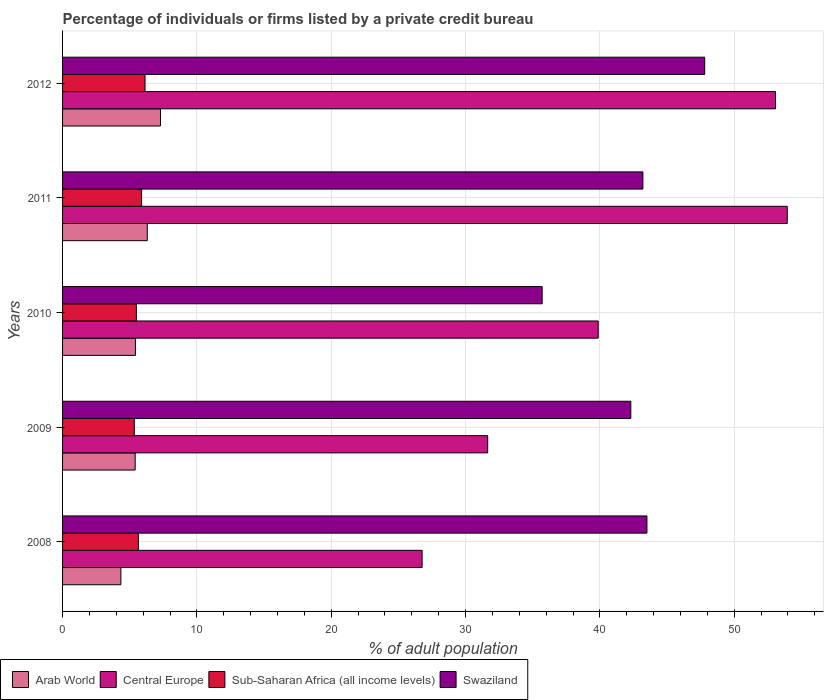How many different coloured bars are there?
Provide a succinct answer. 4. Are the number of bars on each tick of the Y-axis equal?
Provide a short and direct response. Yes. What is the label of the 1st group of bars from the top?
Ensure brevity in your answer.  2012. What is the percentage of population listed by a private credit bureau in Sub-Saharan Africa (all income levels) in 2009?
Offer a terse response. 5.34. Across all years, what is the maximum percentage of population listed by a private credit bureau in Central Europe?
Your answer should be compact. 53.95. Across all years, what is the minimum percentage of population listed by a private credit bureau in Central Europe?
Provide a succinct answer. 26.76. What is the total percentage of population listed by a private credit bureau in Swaziland in the graph?
Ensure brevity in your answer.  212.5. What is the difference between the percentage of population listed by a private credit bureau in Sub-Saharan Africa (all income levels) in 2008 and that in 2011?
Provide a short and direct response. -0.24. What is the difference between the percentage of population listed by a private credit bureau in Central Europe in 2010 and the percentage of population listed by a private credit bureau in Swaziland in 2011?
Make the answer very short. -3.33. What is the average percentage of population listed by a private credit bureau in Swaziland per year?
Keep it short and to the point. 42.5. In the year 2012, what is the difference between the percentage of population listed by a private credit bureau in Arab World and percentage of population listed by a private credit bureau in Sub-Saharan Africa (all income levels)?
Your answer should be very brief. 1.15. In how many years, is the percentage of population listed by a private credit bureau in Swaziland greater than 52 %?
Your answer should be very brief. 0. What is the ratio of the percentage of population listed by a private credit bureau in Central Europe in 2011 to that in 2012?
Keep it short and to the point. 1.02. Is the percentage of population listed by a private credit bureau in Arab World in 2008 less than that in 2012?
Keep it short and to the point. Yes. What is the difference between the highest and the second highest percentage of population listed by a private credit bureau in Arab World?
Keep it short and to the point. 0.99. What is the difference between the highest and the lowest percentage of population listed by a private credit bureau in Swaziland?
Keep it short and to the point. 12.1. What does the 4th bar from the top in 2009 represents?
Offer a very short reply. Arab World. What does the 4th bar from the bottom in 2012 represents?
Keep it short and to the point. Swaziland. Are all the bars in the graph horizontal?
Ensure brevity in your answer.  Yes. What is the difference between two consecutive major ticks on the X-axis?
Your response must be concise. 10. Where does the legend appear in the graph?
Provide a succinct answer. Bottom left. How are the legend labels stacked?
Give a very brief answer. Horizontal. What is the title of the graph?
Offer a terse response. Percentage of individuals or firms listed by a private credit bureau. Does "Malaysia" appear as one of the legend labels in the graph?
Provide a short and direct response. No. What is the label or title of the X-axis?
Your answer should be compact. % of adult population. What is the % of adult population of Arab World in 2008?
Your answer should be compact. 4.34. What is the % of adult population in Central Europe in 2008?
Your answer should be very brief. 26.76. What is the % of adult population of Sub-Saharan Africa (all income levels) in 2008?
Offer a very short reply. 5.64. What is the % of adult population in Swaziland in 2008?
Give a very brief answer. 43.5. What is the % of adult population of Arab World in 2009?
Give a very brief answer. 5.41. What is the % of adult population in Central Europe in 2009?
Your answer should be compact. 31.65. What is the % of adult population of Sub-Saharan Africa (all income levels) in 2009?
Give a very brief answer. 5.34. What is the % of adult population of Swaziland in 2009?
Provide a succinct answer. 42.3. What is the % of adult population in Arab World in 2010?
Give a very brief answer. 5.42. What is the % of adult population in Central Europe in 2010?
Give a very brief answer. 39.87. What is the % of adult population of Sub-Saharan Africa (all income levels) in 2010?
Your answer should be very brief. 5.49. What is the % of adult population of Swaziland in 2010?
Provide a succinct answer. 35.7. What is the % of adult population in Arab World in 2011?
Make the answer very short. 6.3. What is the % of adult population of Central Europe in 2011?
Offer a terse response. 53.95. What is the % of adult population in Sub-Saharan Africa (all income levels) in 2011?
Make the answer very short. 5.88. What is the % of adult population in Swaziland in 2011?
Your response must be concise. 43.2. What is the % of adult population of Arab World in 2012?
Your answer should be very brief. 7.29. What is the % of adult population of Central Europe in 2012?
Your answer should be compact. 53.07. What is the % of adult population of Sub-Saharan Africa (all income levels) in 2012?
Keep it short and to the point. 6.14. What is the % of adult population in Swaziland in 2012?
Provide a succinct answer. 47.8. Across all years, what is the maximum % of adult population of Arab World?
Keep it short and to the point. 7.29. Across all years, what is the maximum % of adult population in Central Europe?
Your answer should be compact. 53.95. Across all years, what is the maximum % of adult population of Sub-Saharan Africa (all income levels)?
Your answer should be compact. 6.14. Across all years, what is the maximum % of adult population in Swaziland?
Ensure brevity in your answer.  47.8. Across all years, what is the minimum % of adult population in Arab World?
Ensure brevity in your answer.  4.34. Across all years, what is the minimum % of adult population of Central Europe?
Give a very brief answer. 26.76. Across all years, what is the minimum % of adult population in Sub-Saharan Africa (all income levels)?
Provide a succinct answer. 5.34. Across all years, what is the minimum % of adult population in Swaziland?
Offer a very short reply. 35.7. What is the total % of adult population in Arab World in the graph?
Make the answer very short. 28.77. What is the total % of adult population of Central Europe in the graph?
Offer a very short reply. 205.3. What is the total % of adult population in Sub-Saharan Africa (all income levels) in the graph?
Your answer should be compact. 28.5. What is the total % of adult population in Swaziland in the graph?
Offer a very short reply. 212.5. What is the difference between the % of adult population in Arab World in 2008 and that in 2009?
Your response must be concise. -1.06. What is the difference between the % of adult population of Central Europe in 2008 and that in 2009?
Ensure brevity in your answer.  -4.88. What is the difference between the % of adult population of Sub-Saharan Africa (all income levels) in 2008 and that in 2009?
Provide a succinct answer. 0.3. What is the difference between the % of adult population of Arab World in 2008 and that in 2010?
Provide a succinct answer. -1.08. What is the difference between the % of adult population of Central Europe in 2008 and that in 2010?
Give a very brief answer. -13.11. What is the difference between the % of adult population of Sub-Saharan Africa (all income levels) in 2008 and that in 2010?
Your answer should be compact. 0.15. What is the difference between the % of adult population of Arab World in 2008 and that in 2011?
Your answer should be very brief. -1.97. What is the difference between the % of adult population of Central Europe in 2008 and that in 2011?
Offer a terse response. -27.18. What is the difference between the % of adult population in Sub-Saharan Africa (all income levels) in 2008 and that in 2011?
Offer a terse response. -0.24. What is the difference between the % of adult population of Arab World in 2008 and that in 2012?
Your answer should be very brief. -2.95. What is the difference between the % of adult population of Central Europe in 2008 and that in 2012?
Make the answer very short. -26.31. What is the difference between the % of adult population in Sub-Saharan Africa (all income levels) in 2008 and that in 2012?
Your response must be concise. -0.49. What is the difference between the % of adult population in Swaziland in 2008 and that in 2012?
Your answer should be compact. -4.3. What is the difference between the % of adult population of Arab World in 2009 and that in 2010?
Your response must be concise. -0.02. What is the difference between the % of adult population in Central Europe in 2009 and that in 2010?
Keep it short and to the point. -8.23. What is the difference between the % of adult population in Sub-Saharan Africa (all income levels) in 2009 and that in 2010?
Keep it short and to the point. -0.15. What is the difference between the % of adult population in Swaziland in 2009 and that in 2010?
Provide a short and direct response. 6.6. What is the difference between the % of adult population in Central Europe in 2009 and that in 2011?
Ensure brevity in your answer.  -22.3. What is the difference between the % of adult population in Sub-Saharan Africa (all income levels) in 2009 and that in 2011?
Your answer should be compact. -0.54. What is the difference between the % of adult population in Swaziland in 2009 and that in 2011?
Offer a very short reply. -0.9. What is the difference between the % of adult population in Arab World in 2009 and that in 2012?
Provide a short and direct response. -1.89. What is the difference between the % of adult population in Central Europe in 2009 and that in 2012?
Provide a short and direct response. -21.43. What is the difference between the % of adult population of Sub-Saharan Africa (all income levels) in 2009 and that in 2012?
Ensure brevity in your answer.  -0.8. What is the difference between the % of adult population of Arab World in 2010 and that in 2011?
Offer a terse response. -0.88. What is the difference between the % of adult population of Central Europe in 2010 and that in 2011?
Your response must be concise. -14.07. What is the difference between the % of adult population in Sub-Saharan Africa (all income levels) in 2010 and that in 2011?
Your answer should be compact. -0.39. What is the difference between the % of adult population in Swaziland in 2010 and that in 2011?
Give a very brief answer. -7.5. What is the difference between the % of adult population in Arab World in 2010 and that in 2012?
Offer a very short reply. -1.87. What is the difference between the % of adult population of Central Europe in 2010 and that in 2012?
Ensure brevity in your answer.  -13.2. What is the difference between the % of adult population in Sub-Saharan Africa (all income levels) in 2010 and that in 2012?
Keep it short and to the point. -0.65. What is the difference between the % of adult population in Swaziland in 2010 and that in 2012?
Keep it short and to the point. -12.1. What is the difference between the % of adult population of Arab World in 2011 and that in 2012?
Offer a very short reply. -0.99. What is the difference between the % of adult population of Central Europe in 2011 and that in 2012?
Make the answer very short. 0.87. What is the difference between the % of adult population in Sub-Saharan Africa (all income levels) in 2011 and that in 2012?
Your answer should be compact. -0.26. What is the difference between the % of adult population in Arab World in 2008 and the % of adult population in Central Europe in 2009?
Your answer should be very brief. -27.31. What is the difference between the % of adult population of Arab World in 2008 and the % of adult population of Swaziland in 2009?
Ensure brevity in your answer.  -37.96. What is the difference between the % of adult population in Central Europe in 2008 and the % of adult population in Sub-Saharan Africa (all income levels) in 2009?
Offer a very short reply. 21.42. What is the difference between the % of adult population of Central Europe in 2008 and the % of adult population of Swaziland in 2009?
Offer a terse response. -15.54. What is the difference between the % of adult population in Sub-Saharan Africa (all income levels) in 2008 and the % of adult population in Swaziland in 2009?
Your answer should be compact. -36.66. What is the difference between the % of adult population in Arab World in 2008 and the % of adult population in Central Europe in 2010?
Provide a succinct answer. -35.53. What is the difference between the % of adult population in Arab World in 2008 and the % of adult population in Sub-Saharan Africa (all income levels) in 2010?
Ensure brevity in your answer.  -1.15. What is the difference between the % of adult population of Arab World in 2008 and the % of adult population of Swaziland in 2010?
Keep it short and to the point. -31.36. What is the difference between the % of adult population of Central Europe in 2008 and the % of adult population of Sub-Saharan Africa (all income levels) in 2010?
Keep it short and to the point. 21.27. What is the difference between the % of adult population of Central Europe in 2008 and the % of adult population of Swaziland in 2010?
Provide a short and direct response. -8.94. What is the difference between the % of adult population of Sub-Saharan Africa (all income levels) in 2008 and the % of adult population of Swaziland in 2010?
Make the answer very short. -30.06. What is the difference between the % of adult population of Arab World in 2008 and the % of adult population of Central Europe in 2011?
Provide a succinct answer. -49.61. What is the difference between the % of adult population in Arab World in 2008 and the % of adult population in Sub-Saharan Africa (all income levels) in 2011?
Your response must be concise. -1.54. What is the difference between the % of adult population in Arab World in 2008 and the % of adult population in Swaziland in 2011?
Provide a short and direct response. -38.86. What is the difference between the % of adult population in Central Europe in 2008 and the % of adult population in Sub-Saharan Africa (all income levels) in 2011?
Your answer should be very brief. 20.88. What is the difference between the % of adult population of Central Europe in 2008 and the % of adult population of Swaziland in 2011?
Ensure brevity in your answer.  -16.44. What is the difference between the % of adult population in Sub-Saharan Africa (all income levels) in 2008 and the % of adult population in Swaziland in 2011?
Provide a short and direct response. -37.56. What is the difference between the % of adult population of Arab World in 2008 and the % of adult population of Central Europe in 2012?
Offer a terse response. -48.73. What is the difference between the % of adult population in Arab World in 2008 and the % of adult population in Sub-Saharan Africa (all income levels) in 2012?
Provide a short and direct response. -1.8. What is the difference between the % of adult population of Arab World in 2008 and the % of adult population of Swaziland in 2012?
Your answer should be very brief. -43.46. What is the difference between the % of adult population in Central Europe in 2008 and the % of adult population in Sub-Saharan Africa (all income levels) in 2012?
Make the answer very short. 20.62. What is the difference between the % of adult population of Central Europe in 2008 and the % of adult population of Swaziland in 2012?
Offer a very short reply. -21.04. What is the difference between the % of adult population of Sub-Saharan Africa (all income levels) in 2008 and the % of adult population of Swaziland in 2012?
Your answer should be very brief. -42.16. What is the difference between the % of adult population in Arab World in 2009 and the % of adult population in Central Europe in 2010?
Keep it short and to the point. -34.47. What is the difference between the % of adult population of Arab World in 2009 and the % of adult population of Sub-Saharan Africa (all income levels) in 2010?
Your answer should be compact. -0.09. What is the difference between the % of adult population of Arab World in 2009 and the % of adult population of Swaziland in 2010?
Keep it short and to the point. -30.3. What is the difference between the % of adult population of Central Europe in 2009 and the % of adult population of Sub-Saharan Africa (all income levels) in 2010?
Provide a short and direct response. 26.15. What is the difference between the % of adult population of Central Europe in 2009 and the % of adult population of Swaziland in 2010?
Offer a terse response. -4.05. What is the difference between the % of adult population of Sub-Saharan Africa (all income levels) in 2009 and the % of adult population of Swaziland in 2010?
Keep it short and to the point. -30.36. What is the difference between the % of adult population in Arab World in 2009 and the % of adult population in Central Europe in 2011?
Offer a very short reply. -48.54. What is the difference between the % of adult population in Arab World in 2009 and the % of adult population in Sub-Saharan Africa (all income levels) in 2011?
Your answer should be very brief. -0.47. What is the difference between the % of adult population of Arab World in 2009 and the % of adult population of Swaziland in 2011?
Your answer should be very brief. -37.8. What is the difference between the % of adult population in Central Europe in 2009 and the % of adult population in Sub-Saharan Africa (all income levels) in 2011?
Your answer should be compact. 25.77. What is the difference between the % of adult population in Central Europe in 2009 and the % of adult population in Swaziland in 2011?
Ensure brevity in your answer.  -11.55. What is the difference between the % of adult population of Sub-Saharan Africa (all income levels) in 2009 and the % of adult population of Swaziland in 2011?
Your response must be concise. -37.86. What is the difference between the % of adult population of Arab World in 2009 and the % of adult population of Central Europe in 2012?
Your answer should be very brief. -47.67. What is the difference between the % of adult population in Arab World in 2009 and the % of adult population in Sub-Saharan Africa (all income levels) in 2012?
Offer a terse response. -0.73. What is the difference between the % of adult population in Arab World in 2009 and the % of adult population in Swaziland in 2012?
Provide a short and direct response. -42.4. What is the difference between the % of adult population of Central Europe in 2009 and the % of adult population of Sub-Saharan Africa (all income levels) in 2012?
Keep it short and to the point. 25.51. What is the difference between the % of adult population of Central Europe in 2009 and the % of adult population of Swaziland in 2012?
Ensure brevity in your answer.  -16.15. What is the difference between the % of adult population of Sub-Saharan Africa (all income levels) in 2009 and the % of adult population of Swaziland in 2012?
Offer a very short reply. -42.46. What is the difference between the % of adult population in Arab World in 2010 and the % of adult population in Central Europe in 2011?
Offer a very short reply. -48.52. What is the difference between the % of adult population in Arab World in 2010 and the % of adult population in Sub-Saharan Africa (all income levels) in 2011?
Provide a succinct answer. -0.46. What is the difference between the % of adult population of Arab World in 2010 and the % of adult population of Swaziland in 2011?
Keep it short and to the point. -37.77. What is the difference between the % of adult population in Central Europe in 2010 and the % of adult population in Sub-Saharan Africa (all income levels) in 2011?
Provide a short and direct response. 33.99. What is the difference between the % of adult population in Central Europe in 2010 and the % of adult population in Swaziland in 2011?
Give a very brief answer. -3.33. What is the difference between the % of adult population of Sub-Saharan Africa (all income levels) in 2010 and the % of adult population of Swaziland in 2011?
Your answer should be compact. -37.71. What is the difference between the % of adult population of Arab World in 2010 and the % of adult population of Central Europe in 2012?
Your answer should be compact. -47.65. What is the difference between the % of adult population of Arab World in 2010 and the % of adult population of Sub-Saharan Africa (all income levels) in 2012?
Provide a short and direct response. -0.71. What is the difference between the % of adult population of Arab World in 2010 and the % of adult population of Swaziland in 2012?
Make the answer very short. -42.38. What is the difference between the % of adult population in Central Europe in 2010 and the % of adult population in Sub-Saharan Africa (all income levels) in 2012?
Ensure brevity in your answer.  33.73. What is the difference between the % of adult population of Central Europe in 2010 and the % of adult population of Swaziland in 2012?
Your answer should be very brief. -7.93. What is the difference between the % of adult population in Sub-Saharan Africa (all income levels) in 2010 and the % of adult population in Swaziland in 2012?
Keep it short and to the point. -42.31. What is the difference between the % of adult population of Arab World in 2011 and the % of adult population of Central Europe in 2012?
Ensure brevity in your answer.  -46.77. What is the difference between the % of adult population of Arab World in 2011 and the % of adult population of Sub-Saharan Africa (all income levels) in 2012?
Offer a terse response. 0.17. What is the difference between the % of adult population in Arab World in 2011 and the % of adult population in Swaziland in 2012?
Offer a very short reply. -41.49. What is the difference between the % of adult population of Central Europe in 2011 and the % of adult population of Sub-Saharan Africa (all income levels) in 2012?
Make the answer very short. 47.81. What is the difference between the % of adult population of Central Europe in 2011 and the % of adult population of Swaziland in 2012?
Your answer should be very brief. 6.15. What is the difference between the % of adult population in Sub-Saharan Africa (all income levels) in 2011 and the % of adult population in Swaziland in 2012?
Offer a very short reply. -41.92. What is the average % of adult population of Arab World per year?
Provide a short and direct response. 5.75. What is the average % of adult population of Central Europe per year?
Give a very brief answer. 41.06. What is the average % of adult population in Sub-Saharan Africa (all income levels) per year?
Offer a terse response. 5.7. What is the average % of adult population of Swaziland per year?
Your response must be concise. 42.5. In the year 2008, what is the difference between the % of adult population of Arab World and % of adult population of Central Europe?
Offer a terse response. -22.42. In the year 2008, what is the difference between the % of adult population of Arab World and % of adult population of Sub-Saharan Africa (all income levels)?
Provide a short and direct response. -1.3. In the year 2008, what is the difference between the % of adult population in Arab World and % of adult population in Swaziland?
Make the answer very short. -39.16. In the year 2008, what is the difference between the % of adult population of Central Europe and % of adult population of Sub-Saharan Africa (all income levels)?
Your response must be concise. 21.12. In the year 2008, what is the difference between the % of adult population of Central Europe and % of adult population of Swaziland?
Offer a terse response. -16.74. In the year 2008, what is the difference between the % of adult population in Sub-Saharan Africa (all income levels) and % of adult population in Swaziland?
Offer a very short reply. -37.86. In the year 2009, what is the difference between the % of adult population of Arab World and % of adult population of Central Europe?
Your answer should be compact. -26.24. In the year 2009, what is the difference between the % of adult population of Arab World and % of adult population of Sub-Saharan Africa (all income levels)?
Make the answer very short. 0.07. In the year 2009, what is the difference between the % of adult population of Arab World and % of adult population of Swaziland?
Ensure brevity in your answer.  -36.9. In the year 2009, what is the difference between the % of adult population in Central Europe and % of adult population in Sub-Saharan Africa (all income levels)?
Provide a succinct answer. 26.31. In the year 2009, what is the difference between the % of adult population in Central Europe and % of adult population in Swaziland?
Provide a short and direct response. -10.65. In the year 2009, what is the difference between the % of adult population of Sub-Saharan Africa (all income levels) and % of adult population of Swaziland?
Make the answer very short. -36.96. In the year 2010, what is the difference between the % of adult population of Arab World and % of adult population of Central Europe?
Give a very brief answer. -34.45. In the year 2010, what is the difference between the % of adult population in Arab World and % of adult population in Sub-Saharan Africa (all income levels)?
Provide a succinct answer. -0.07. In the year 2010, what is the difference between the % of adult population in Arab World and % of adult population in Swaziland?
Give a very brief answer. -30.27. In the year 2010, what is the difference between the % of adult population in Central Europe and % of adult population in Sub-Saharan Africa (all income levels)?
Your answer should be very brief. 34.38. In the year 2010, what is the difference between the % of adult population of Central Europe and % of adult population of Swaziland?
Your answer should be compact. 4.17. In the year 2010, what is the difference between the % of adult population of Sub-Saharan Africa (all income levels) and % of adult population of Swaziland?
Offer a terse response. -30.21. In the year 2011, what is the difference between the % of adult population of Arab World and % of adult population of Central Europe?
Make the answer very short. -47.64. In the year 2011, what is the difference between the % of adult population in Arab World and % of adult population in Sub-Saharan Africa (all income levels)?
Ensure brevity in your answer.  0.42. In the year 2011, what is the difference between the % of adult population in Arab World and % of adult population in Swaziland?
Provide a succinct answer. -36.9. In the year 2011, what is the difference between the % of adult population in Central Europe and % of adult population in Sub-Saharan Africa (all income levels)?
Make the answer very short. 48.07. In the year 2011, what is the difference between the % of adult population in Central Europe and % of adult population in Swaziland?
Keep it short and to the point. 10.75. In the year 2011, what is the difference between the % of adult population in Sub-Saharan Africa (all income levels) and % of adult population in Swaziland?
Ensure brevity in your answer.  -37.32. In the year 2012, what is the difference between the % of adult population in Arab World and % of adult population in Central Europe?
Make the answer very short. -45.78. In the year 2012, what is the difference between the % of adult population in Arab World and % of adult population in Sub-Saharan Africa (all income levels)?
Provide a short and direct response. 1.15. In the year 2012, what is the difference between the % of adult population in Arab World and % of adult population in Swaziland?
Make the answer very short. -40.51. In the year 2012, what is the difference between the % of adult population in Central Europe and % of adult population in Sub-Saharan Africa (all income levels)?
Provide a succinct answer. 46.93. In the year 2012, what is the difference between the % of adult population in Central Europe and % of adult population in Swaziland?
Offer a terse response. 5.27. In the year 2012, what is the difference between the % of adult population in Sub-Saharan Africa (all income levels) and % of adult population in Swaziland?
Offer a terse response. -41.66. What is the ratio of the % of adult population of Arab World in 2008 to that in 2009?
Offer a terse response. 0.8. What is the ratio of the % of adult population in Central Europe in 2008 to that in 2009?
Offer a very short reply. 0.85. What is the ratio of the % of adult population of Sub-Saharan Africa (all income levels) in 2008 to that in 2009?
Ensure brevity in your answer.  1.06. What is the ratio of the % of adult population in Swaziland in 2008 to that in 2009?
Your answer should be very brief. 1.03. What is the ratio of the % of adult population of Arab World in 2008 to that in 2010?
Offer a very short reply. 0.8. What is the ratio of the % of adult population of Central Europe in 2008 to that in 2010?
Offer a very short reply. 0.67. What is the ratio of the % of adult population of Sub-Saharan Africa (all income levels) in 2008 to that in 2010?
Offer a terse response. 1.03. What is the ratio of the % of adult population in Swaziland in 2008 to that in 2010?
Give a very brief answer. 1.22. What is the ratio of the % of adult population of Arab World in 2008 to that in 2011?
Your answer should be compact. 0.69. What is the ratio of the % of adult population of Central Europe in 2008 to that in 2011?
Provide a succinct answer. 0.5. What is the ratio of the % of adult population in Sub-Saharan Africa (all income levels) in 2008 to that in 2011?
Your answer should be very brief. 0.96. What is the ratio of the % of adult population in Arab World in 2008 to that in 2012?
Your answer should be very brief. 0.6. What is the ratio of the % of adult population in Central Europe in 2008 to that in 2012?
Give a very brief answer. 0.5. What is the ratio of the % of adult population of Sub-Saharan Africa (all income levels) in 2008 to that in 2012?
Make the answer very short. 0.92. What is the ratio of the % of adult population of Swaziland in 2008 to that in 2012?
Your response must be concise. 0.91. What is the ratio of the % of adult population in Arab World in 2009 to that in 2010?
Provide a succinct answer. 1. What is the ratio of the % of adult population of Central Europe in 2009 to that in 2010?
Provide a succinct answer. 0.79. What is the ratio of the % of adult population in Sub-Saharan Africa (all income levels) in 2009 to that in 2010?
Your response must be concise. 0.97. What is the ratio of the % of adult population in Swaziland in 2009 to that in 2010?
Your answer should be very brief. 1.18. What is the ratio of the % of adult population in Arab World in 2009 to that in 2011?
Provide a succinct answer. 0.86. What is the ratio of the % of adult population of Central Europe in 2009 to that in 2011?
Keep it short and to the point. 0.59. What is the ratio of the % of adult population in Sub-Saharan Africa (all income levels) in 2009 to that in 2011?
Your answer should be very brief. 0.91. What is the ratio of the % of adult population of Swaziland in 2009 to that in 2011?
Keep it short and to the point. 0.98. What is the ratio of the % of adult population of Arab World in 2009 to that in 2012?
Provide a short and direct response. 0.74. What is the ratio of the % of adult population of Central Europe in 2009 to that in 2012?
Provide a succinct answer. 0.6. What is the ratio of the % of adult population of Sub-Saharan Africa (all income levels) in 2009 to that in 2012?
Make the answer very short. 0.87. What is the ratio of the % of adult population of Swaziland in 2009 to that in 2012?
Your answer should be very brief. 0.88. What is the ratio of the % of adult population of Arab World in 2010 to that in 2011?
Ensure brevity in your answer.  0.86. What is the ratio of the % of adult population of Central Europe in 2010 to that in 2011?
Make the answer very short. 0.74. What is the ratio of the % of adult population of Sub-Saharan Africa (all income levels) in 2010 to that in 2011?
Your response must be concise. 0.93. What is the ratio of the % of adult population of Swaziland in 2010 to that in 2011?
Keep it short and to the point. 0.83. What is the ratio of the % of adult population in Arab World in 2010 to that in 2012?
Your response must be concise. 0.74. What is the ratio of the % of adult population of Central Europe in 2010 to that in 2012?
Keep it short and to the point. 0.75. What is the ratio of the % of adult population in Sub-Saharan Africa (all income levels) in 2010 to that in 2012?
Ensure brevity in your answer.  0.89. What is the ratio of the % of adult population of Swaziland in 2010 to that in 2012?
Provide a succinct answer. 0.75. What is the ratio of the % of adult population in Arab World in 2011 to that in 2012?
Offer a terse response. 0.86. What is the ratio of the % of adult population of Central Europe in 2011 to that in 2012?
Ensure brevity in your answer.  1.02. What is the ratio of the % of adult population in Sub-Saharan Africa (all income levels) in 2011 to that in 2012?
Your answer should be very brief. 0.96. What is the ratio of the % of adult population in Swaziland in 2011 to that in 2012?
Provide a succinct answer. 0.9. What is the difference between the highest and the second highest % of adult population in Arab World?
Ensure brevity in your answer.  0.99. What is the difference between the highest and the second highest % of adult population of Central Europe?
Provide a succinct answer. 0.87. What is the difference between the highest and the second highest % of adult population in Sub-Saharan Africa (all income levels)?
Ensure brevity in your answer.  0.26. What is the difference between the highest and the lowest % of adult population in Arab World?
Your answer should be very brief. 2.95. What is the difference between the highest and the lowest % of adult population of Central Europe?
Make the answer very short. 27.18. What is the difference between the highest and the lowest % of adult population of Sub-Saharan Africa (all income levels)?
Provide a succinct answer. 0.8. 